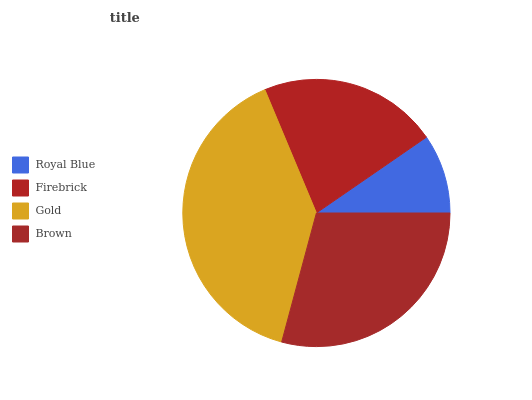Is Royal Blue the minimum?
Answer yes or no. Yes. Is Gold the maximum?
Answer yes or no. Yes. Is Firebrick the minimum?
Answer yes or no. No. Is Firebrick the maximum?
Answer yes or no. No. Is Firebrick greater than Royal Blue?
Answer yes or no. Yes. Is Royal Blue less than Firebrick?
Answer yes or no. Yes. Is Royal Blue greater than Firebrick?
Answer yes or no. No. Is Firebrick less than Royal Blue?
Answer yes or no. No. Is Brown the high median?
Answer yes or no. Yes. Is Firebrick the low median?
Answer yes or no. Yes. Is Gold the high median?
Answer yes or no. No. Is Royal Blue the low median?
Answer yes or no. No. 